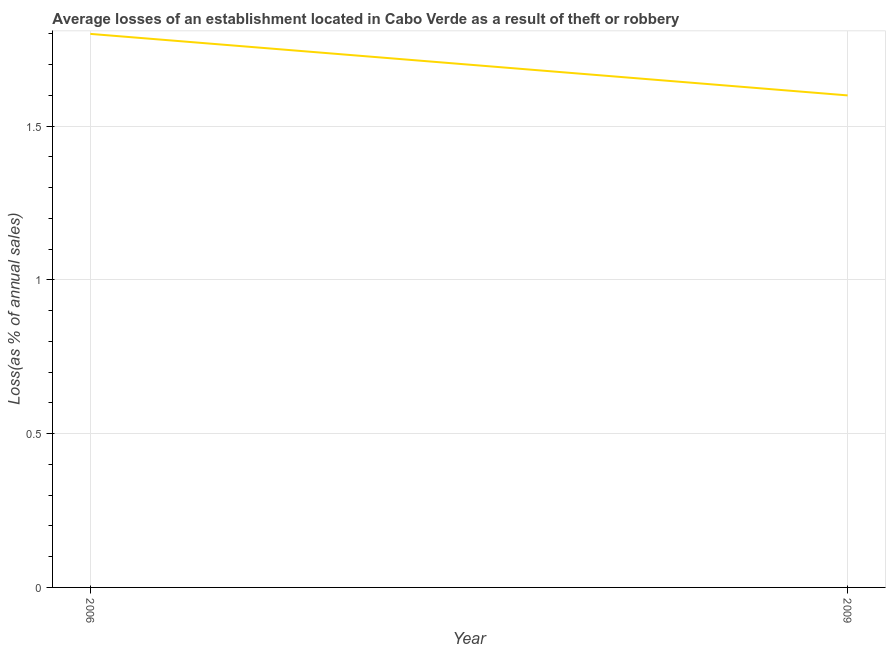What is the losses due to theft in 2006?
Ensure brevity in your answer.  1.8. Across all years, what is the maximum losses due to theft?
Your answer should be very brief. 1.8. Across all years, what is the minimum losses due to theft?
Ensure brevity in your answer.  1.6. What is the sum of the losses due to theft?
Keep it short and to the point. 3.4. What is the difference between the losses due to theft in 2006 and 2009?
Your response must be concise. 0.2. What is the average losses due to theft per year?
Give a very brief answer. 1.7. What is the median losses due to theft?
Your answer should be very brief. 1.7. In how many years, is the losses due to theft greater than 0.1 %?
Your response must be concise. 2. Is the losses due to theft in 2006 less than that in 2009?
Ensure brevity in your answer.  No. How many lines are there?
Provide a succinct answer. 1. Are the values on the major ticks of Y-axis written in scientific E-notation?
Provide a short and direct response. No. Does the graph contain any zero values?
Provide a short and direct response. No. Does the graph contain grids?
Make the answer very short. Yes. What is the title of the graph?
Provide a succinct answer. Average losses of an establishment located in Cabo Verde as a result of theft or robbery. What is the label or title of the X-axis?
Provide a succinct answer. Year. What is the label or title of the Y-axis?
Your answer should be compact. Loss(as % of annual sales). What is the Loss(as % of annual sales) of 2009?
Offer a very short reply. 1.6. What is the difference between the Loss(as % of annual sales) in 2006 and 2009?
Offer a terse response. 0.2. What is the ratio of the Loss(as % of annual sales) in 2006 to that in 2009?
Make the answer very short. 1.12. 